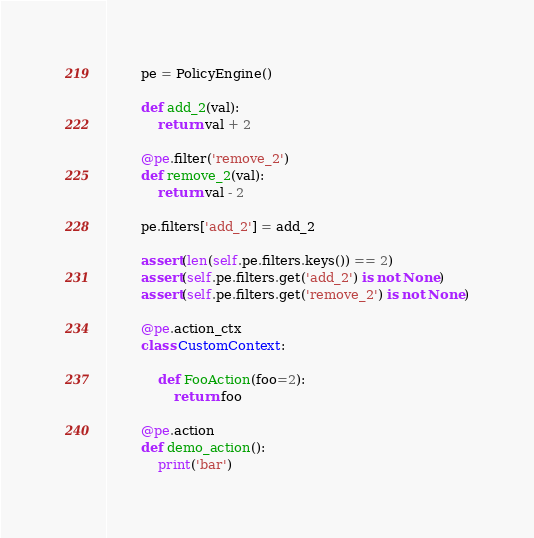<code> <loc_0><loc_0><loc_500><loc_500><_Python_>        pe = PolicyEngine()

        def add_2(val):
            return val + 2

        @pe.filter('remove_2')
        def remove_2(val):
            return val - 2

        pe.filters['add_2'] = add_2

        assert(len(self.pe.filters.keys()) == 2)
        assert(self.pe.filters.get('add_2') is not None)
        assert(self.pe.filters.get('remove_2') is not None)

        @pe.action_ctx
        class CustomContext:

            def FooAction(foo=2):
                return foo

        @pe.action
        def demo_action():
            print('bar')
</code> 